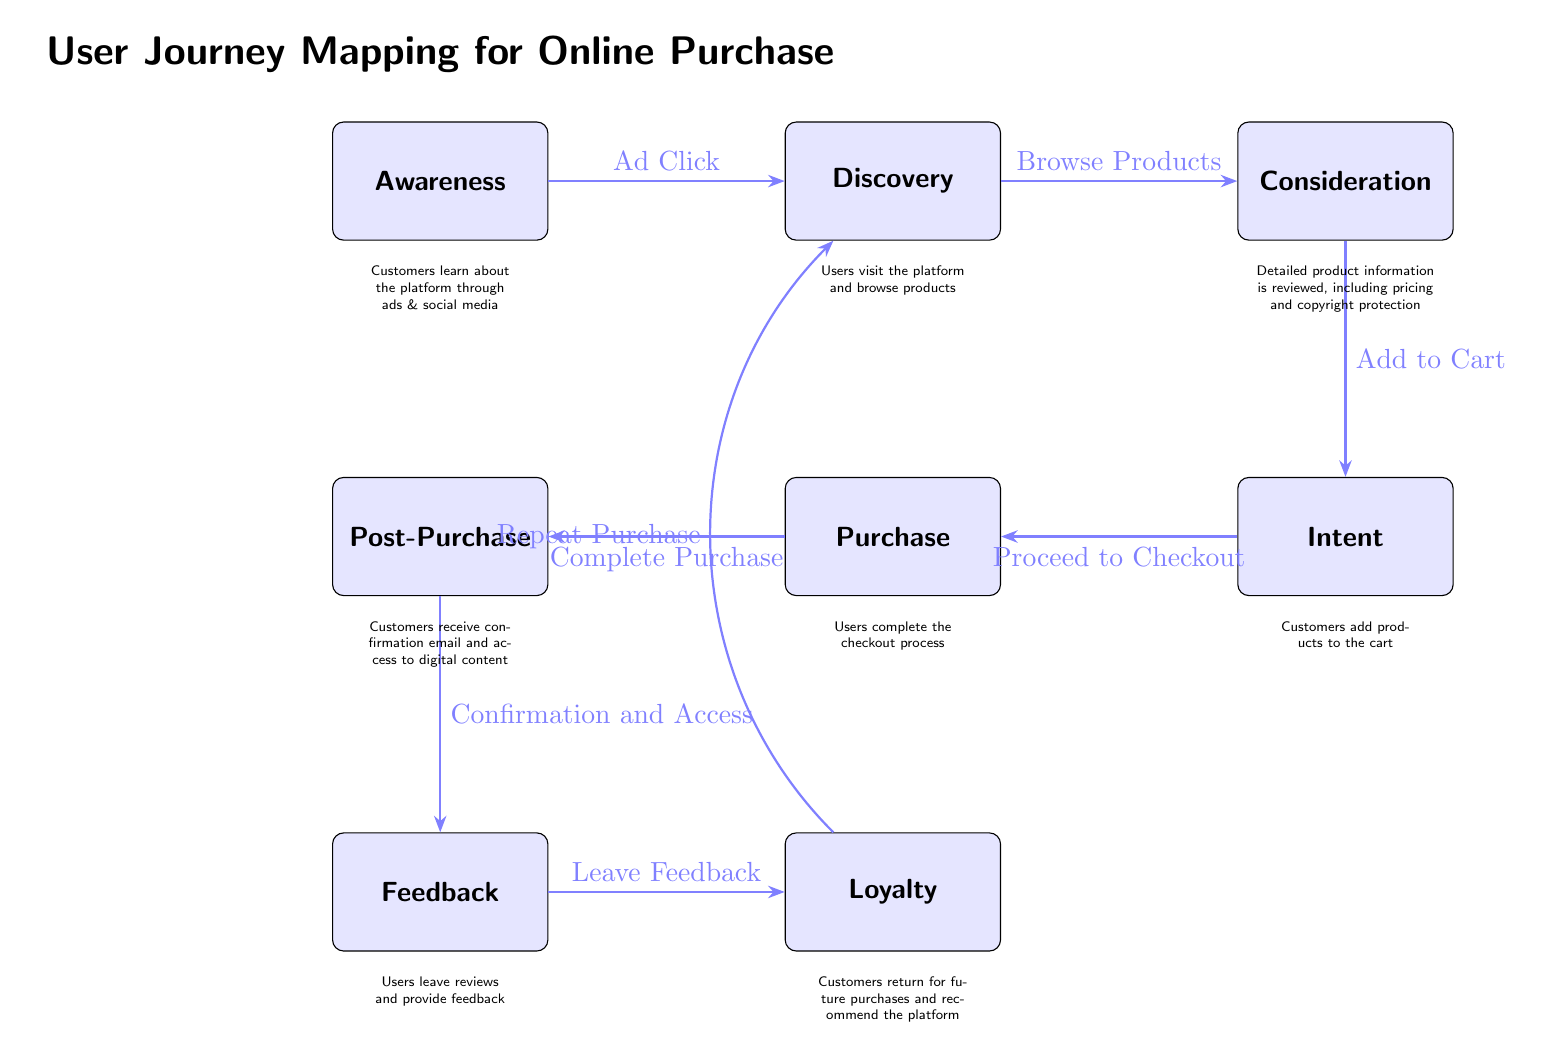What is the first stage in the user journey? The first stage in the user journey is labeled as "Awareness" in the diagram. This is the initial point where customers learn about the platform.
Answer: Awareness How many nodes are present in the diagram? The diagram contains a total of eight nodes, each representing a distinct stage in the user journey from awareness to loyalty.
Answer: 8 What action leads from "Consideration" to "Intent"? The action that leads from "Consideration" to "Intent" is identified as "Add to Cart." This is the transition where users show their intention to purchase.
Answer: Add to Cart What follows "Complete Purchase" in the user journey? Following "Complete Purchase," the next stage is "Post-Purchase." This indicates the activities that occur after the transaction has been completed.
Answer: Post-Purchase How does the user return to the discovery phase in the diagram? Users return to the discovery phase from "Loyalty" through the action labeled "Repeat Purchase." This shows the cyclical nature of customer engagement with the platform.
Answer: Repeat Purchase What is the primary purpose of the "Feedback" stage? The primary purpose of the "Feedback" stage is to allow users to "Leave Feedback," which is crucial for assessing customer satisfaction and improving services.
Answer: Leave Feedback What relationship exists between "Post-Purchase" and "Loyalty"? "Post-Purchase" and "Loyalty" are directly connected through the action "Leave Feedback," indicating that feedback contributes to customer loyalty.
Answer: Leave Feedback Which action connects "Awareness" to "Discovery"? The action that connects "Awareness" to "Discovery" is "Ad Click," indicating the method through which potential customers first engage with the platform.
Answer: Ad Click What provides additional information about the "Consideration" stage? The additional information about the "Consideration" stage includes reviewing detailed product information, pricing, and copyright protection, emphasizing the factors users evaluate before buying.
Answer: Detailed product information is reviewed, including pricing and copyright protection 